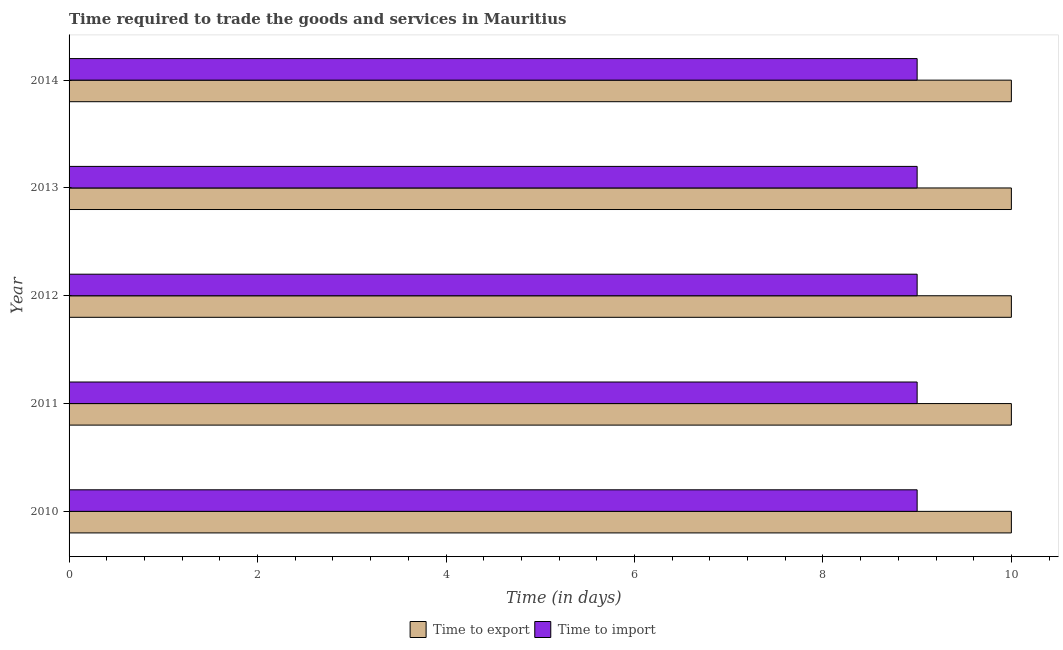How many different coloured bars are there?
Your response must be concise. 2. Are the number of bars per tick equal to the number of legend labels?
Your answer should be very brief. Yes. Are the number of bars on each tick of the Y-axis equal?
Your answer should be compact. Yes. What is the label of the 5th group of bars from the top?
Your response must be concise. 2010. What is the time to import in 2014?
Your answer should be very brief. 9. Across all years, what is the maximum time to export?
Give a very brief answer. 10. Across all years, what is the minimum time to export?
Offer a very short reply. 10. In which year was the time to export maximum?
Your response must be concise. 2010. What is the total time to import in the graph?
Your answer should be very brief. 45. What is the difference between the time to export in 2010 and that in 2013?
Offer a very short reply. 0. What is the difference between the time to import in 2013 and the time to export in 2012?
Provide a short and direct response. -1. In the year 2014, what is the difference between the time to export and time to import?
Your response must be concise. 1. Is the time to import in 2011 less than that in 2012?
Make the answer very short. No. Is the difference between the time to export in 2013 and 2014 greater than the difference between the time to import in 2013 and 2014?
Offer a very short reply. No. What is the difference between the highest and the second highest time to import?
Offer a very short reply. 0. In how many years, is the time to import greater than the average time to import taken over all years?
Provide a succinct answer. 0. Is the sum of the time to export in 2013 and 2014 greater than the maximum time to import across all years?
Offer a very short reply. Yes. What does the 1st bar from the top in 2013 represents?
Ensure brevity in your answer.  Time to import. What does the 1st bar from the bottom in 2013 represents?
Your answer should be compact. Time to export. How many years are there in the graph?
Keep it short and to the point. 5. Are the values on the major ticks of X-axis written in scientific E-notation?
Your answer should be very brief. No. Does the graph contain any zero values?
Offer a very short reply. No. Where does the legend appear in the graph?
Ensure brevity in your answer.  Bottom center. How many legend labels are there?
Offer a terse response. 2. What is the title of the graph?
Provide a succinct answer. Time required to trade the goods and services in Mauritius. What is the label or title of the X-axis?
Make the answer very short. Time (in days). What is the Time (in days) in Time to export in 2010?
Give a very brief answer. 10. What is the Time (in days) of Time to export in 2011?
Make the answer very short. 10. What is the Time (in days) of Time to export in 2012?
Ensure brevity in your answer.  10. What is the Time (in days) of Time to export in 2013?
Offer a very short reply. 10. What is the Time (in days) of Time to import in 2013?
Keep it short and to the point. 9. Across all years, what is the maximum Time (in days) of Time to export?
Your response must be concise. 10. What is the total Time (in days) in Time to export in the graph?
Provide a short and direct response. 50. What is the difference between the Time (in days) of Time to export in 2010 and that in 2011?
Your response must be concise. 0. What is the difference between the Time (in days) in Time to export in 2010 and that in 2012?
Your response must be concise. 0. What is the difference between the Time (in days) of Time to import in 2010 and that in 2012?
Offer a terse response. 0. What is the difference between the Time (in days) in Time to export in 2010 and that in 2013?
Your answer should be very brief. 0. What is the difference between the Time (in days) of Time to import in 2010 and that in 2013?
Give a very brief answer. 0. What is the difference between the Time (in days) in Time to import in 2010 and that in 2014?
Your answer should be very brief. 0. What is the difference between the Time (in days) in Time to export in 2011 and that in 2012?
Keep it short and to the point. 0. What is the difference between the Time (in days) in Time to import in 2011 and that in 2013?
Offer a very short reply. 0. What is the difference between the Time (in days) of Time to export in 2012 and that in 2014?
Your answer should be very brief. 0. What is the difference between the Time (in days) in Time to export in 2013 and that in 2014?
Your response must be concise. 0. What is the difference between the Time (in days) of Time to import in 2013 and that in 2014?
Your answer should be compact. 0. What is the difference between the Time (in days) in Time to export in 2010 and the Time (in days) in Time to import in 2011?
Your response must be concise. 1. What is the difference between the Time (in days) of Time to export in 2010 and the Time (in days) of Time to import in 2012?
Provide a succinct answer. 1. What is the difference between the Time (in days) in Time to export in 2010 and the Time (in days) in Time to import in 2013?
Provide a short and direct response. 1. What is the difference between the Time (in days) in Time to export in 2010 and the Time (in days) in Time to import in 2014?
Your response must be concise. 1. What is the difference between the Time (in days) of Time to export in 2011 and the Time (in days) of Time to import in 2013?
Provide a short and direct response. 1. What is the difference between the Time (in days) of Time to export in 2011 and the Time (in days) of Time to import in 2014?
Ensure brevity in your answer.  1. What is the difference between the Time (in days) of Time to export in 2012 and the Time (in days) of Time to import in 2013?
Offer a very short reply. 1. What is the difference between the Time (in days) in Time to export in 2013 and the Time (in days) in Time to import in 2014?
Ensure brevity in your answer.  1. In the year 2010, what is the difference between the Time (in days) of Time to export and Time (in days) of Time to import?
Your answer should be very brief. 1. In the year 2011, what is the difference between the Time (in days) of Time to export and Time (in days) of Time to import?
Your response must be concise. 1. What is the ratio of the Time (in days) in Time to import in 2010 to that in 2011?
Provide a short and direct response. 1. What is the ratio of the Time (in days) of Time to export in 2010 to that in 2012?
Offer a terse response. 1. What is the ratio of the Time (in days) in Time to import in 2010 to that in 2014?
Your answer should be very brief. 1. What is the ratio of the Time (in days) in Time to export in 2011 to that in 2012?
Your answer should be compact. 1. What is the ratio of the Time (in days) of Time to export in 2011 to that in 2013?
Your answer should be very brief. 1. What is the ratio of the Time (in days) of Time to import in 2011 to that in 2014?
Give a very brief answer. 1. What is the ratio of the Time (in days) in Time to export in 2012 to that in 2013?
Make the answer very short. 1. What is the ratio of the Time (in days) in Time to export in 2013 to that in 2014?
Ensure brevity in your answer.  1. What is the ratio of the Time (in days) of Time to import in 2013 to that in 2014?
Offer a terse response. 1. What is the difference between the highest and the second highest Time (in days) of Time to export?
Your answer should be very brief. 0. What is the difference between the highest and the second highest Time (in days) in Time to import?
Give a very brief answer. 0. 